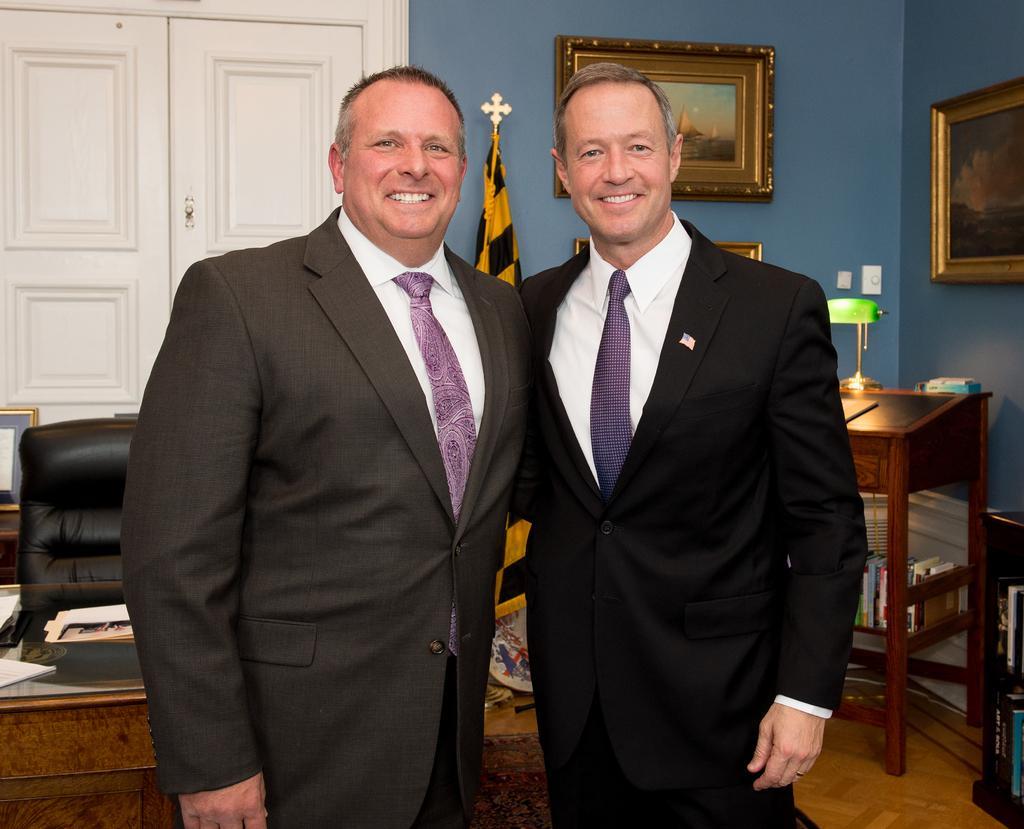Can you describe this image briefly? In this image I can see two men are standing and also I can see smile on their faces. I can see both of them are wearing suit and tie. In the background I can see a chair, a table, a door, a flag and few frames on these walls. I can see a lamp and few books. 